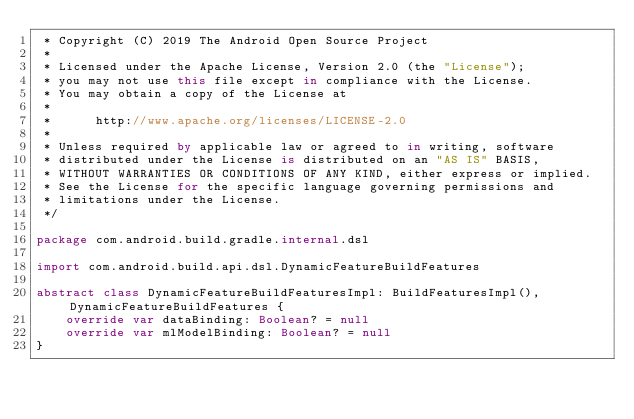<code> <loc_0><loc_0><loc_500><loc_500><_Kotlin_> * Copyright (C) 2019 The Android Open Source Project
 *
 * Licensed under the Apache License, Version 2.0 (the "License");
 * you may not use this file except in compliance with the License.
 * You may obtain a copy of the License at
 *
 *      http://www.apache.org/licenses/LICENSE-2.0
 *
 * Unless required by applicable law or agreed to in writing, software
 * distributed under the License is distributed on an "AS IS" BASIS,
 * WITHOUT WARRANTIES OR CONDITIONS OF ANY KIND, either express or implied.
 * See the License for the specific language governing permissions and
 * limitations under the License.
 */

package com.android.build.gradle.internal.dsl

import com.android.build.api.dsl.DynamicFeatureBuildFeatures

abstract class DynamicFeatureBuildFeaturesImpl: BuildFeaturesImpl(), DynamicFeatureBuildFeatures {
    override var dataBinding: Boolean? = null
    override var mlModelBinding: Boolean? = null
}</code> 